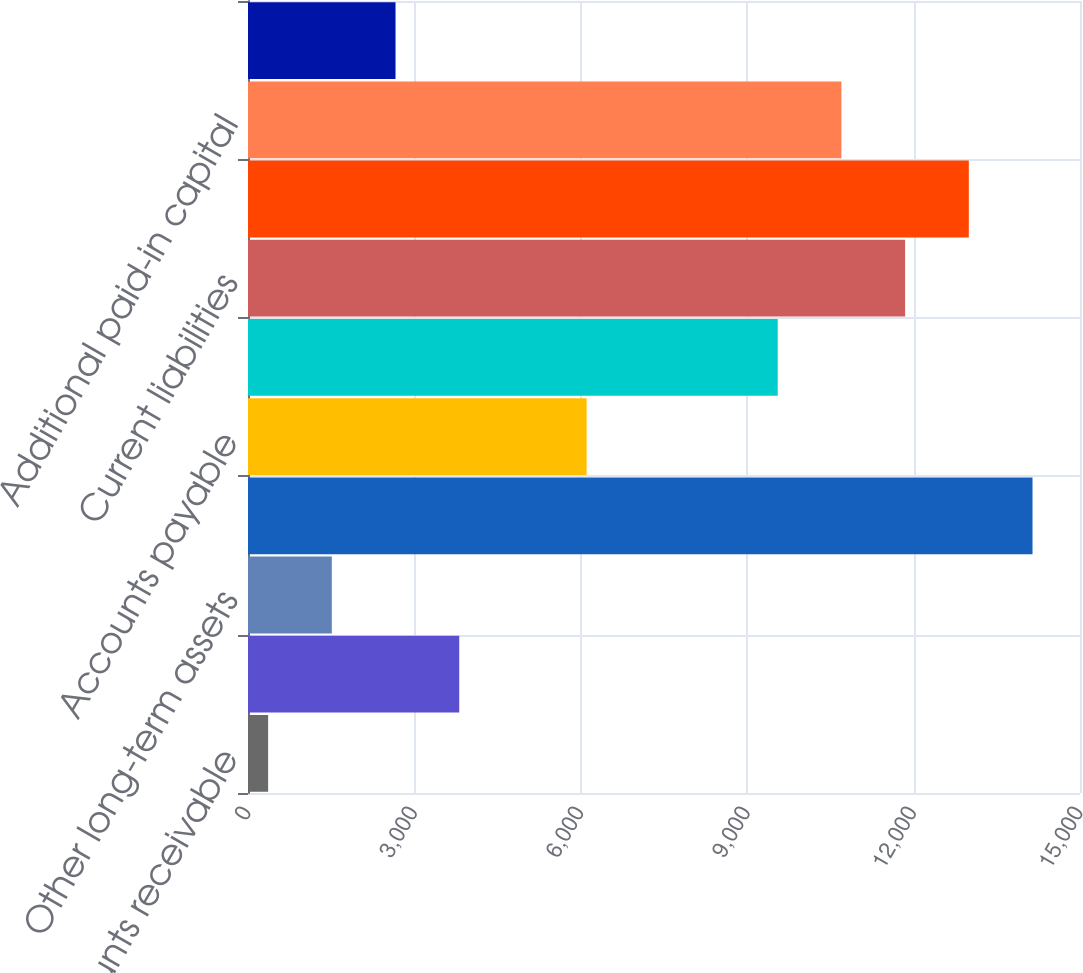<chart> <loc_0><loc_0><loc_500><loc_500><bar_chart><fcel>Accounts receivable<fcel>Current assets<fcel>Other long-term assets<fcel>Total assets<fcel>Accounts payable<fcel>Other current liabilities<fcel>Current liabilities<fcel>Total liabilities<fcel>Additional paid-in capital<fcel>Accumulated other<nl><fcel>363<fcel>3808.2<fcel>1511.4<fcel>14143.8<fcel>6105<fcel>9550.2<fcel>11847<fcel>12995.4<fcel>10698.6<fcel>2659.8<nl></chart> 